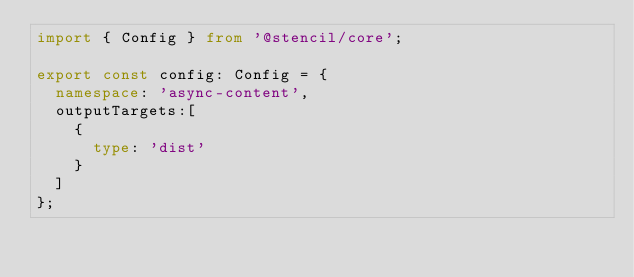<code> <loc_0><loc_0><loc_500><loc_500><_TypeScript_>import { Config } from '@stencil/core';

export const config: Config = {
  namespace: 'async-content',
  outputTargets:[
    {
      type: 'dist'
    }
  ]
};
</code> 